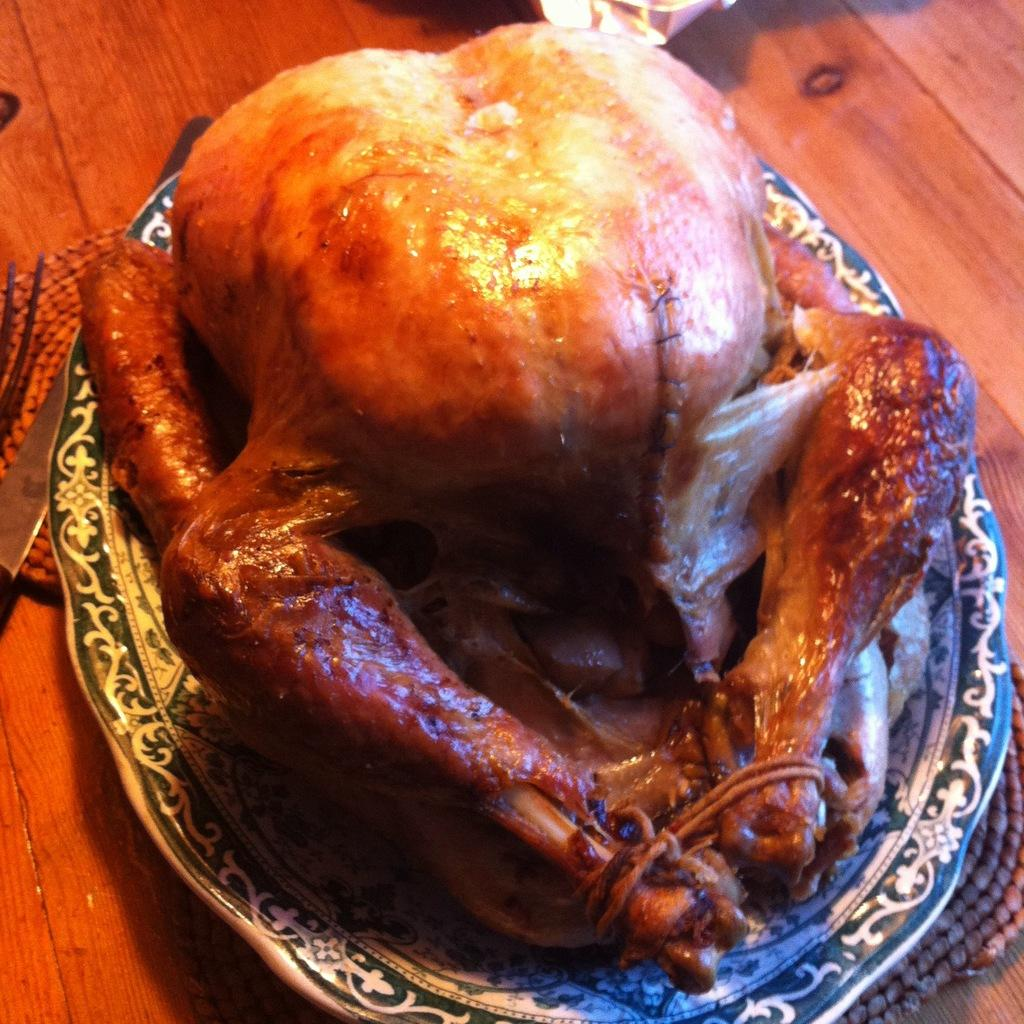What is the main dish on the plate in the image? There is a roasted chicken on a plate in the image. Where is the plate with the chicken located? The plate is placed on a table. What utensil is beside the plate? There is a knife beside the plate. What type of butter is being used to paint the point on the nail in the image? There is no butter, point, or nail present in the image; it features a roasted chicken on a plate with a knife beside it. 